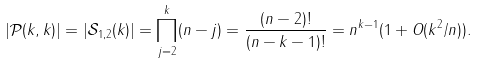Convert formula to latex. <formula><loc_0><loc_0><loc_500><loc_500>| \mathcal { P } ( k , k ) | = | \mathcal { S } _ { 1 , 2 } ( k ) | = \prod _ { j = 2 } ^ { k } ( n - j ) = \frac { ( n - 2 ) ! } { ( n - k - 1 ) ! } = n ^ { k - 1 } ( 1 + O ( k ^ { 2 } / n ) ) .</formula> 